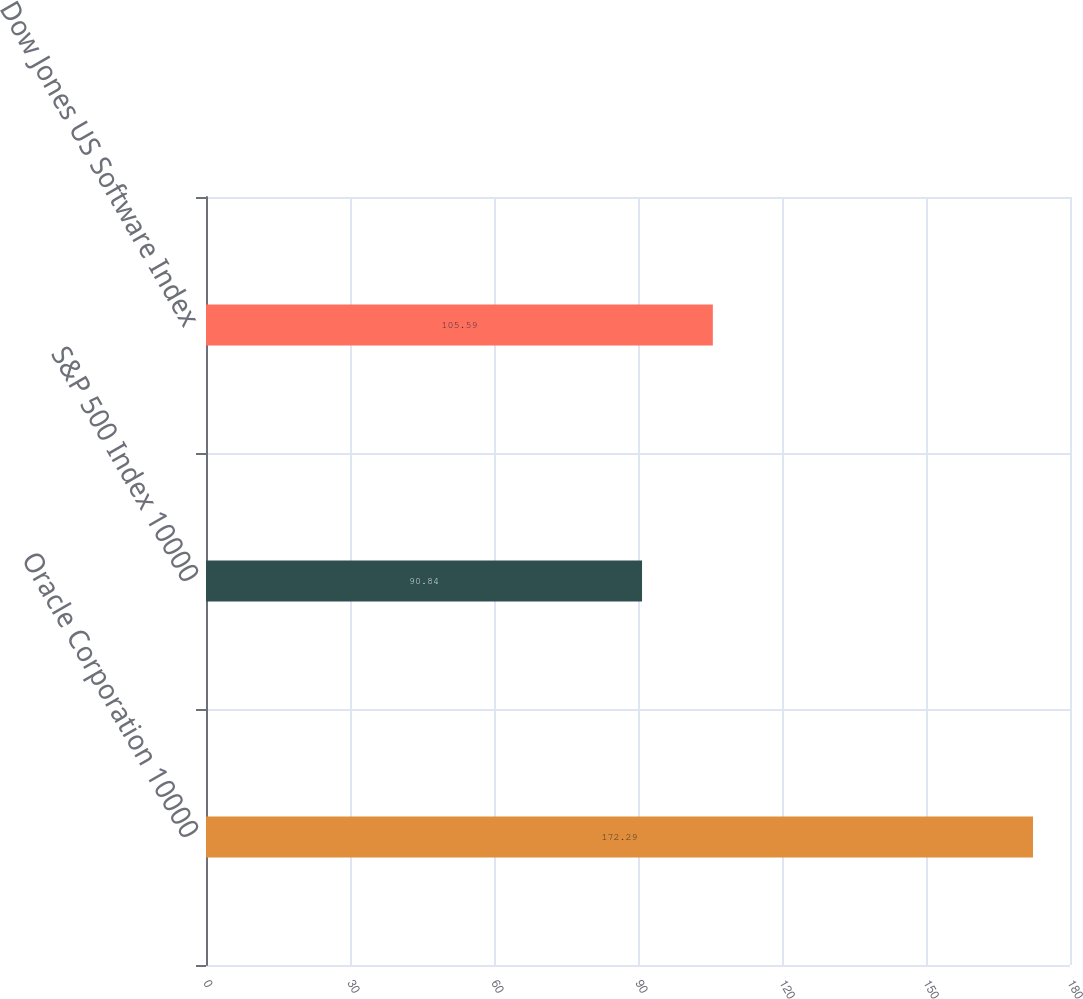Convert chart. <chart><loc_0><loc_0><loc_500><loc_500><bar_chart><fcel>Oracle Corporation 10000<fcel>S&P 500 Index 10000<fcel>Dow Jones US Software Index<nl><fcel>172.29<fcel>90.84<fcel>105.59<nl></chart> 